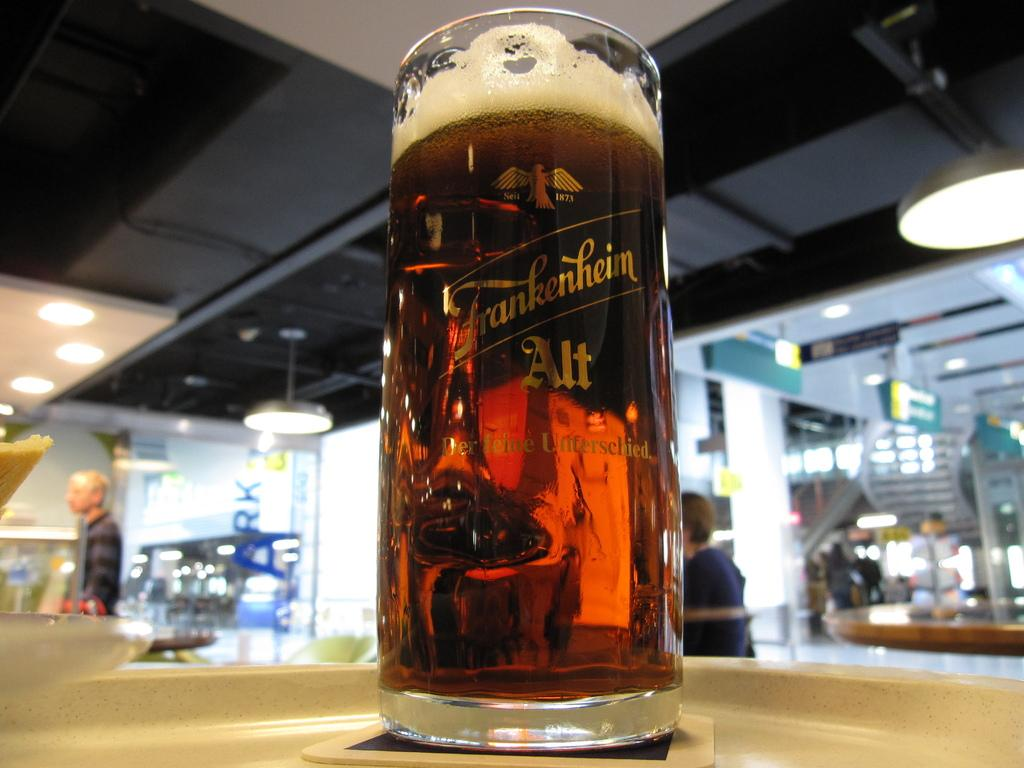<image>
Present a compact description of the photo's key features. a tall Frankenhein glass of beer sitting on a bar top 